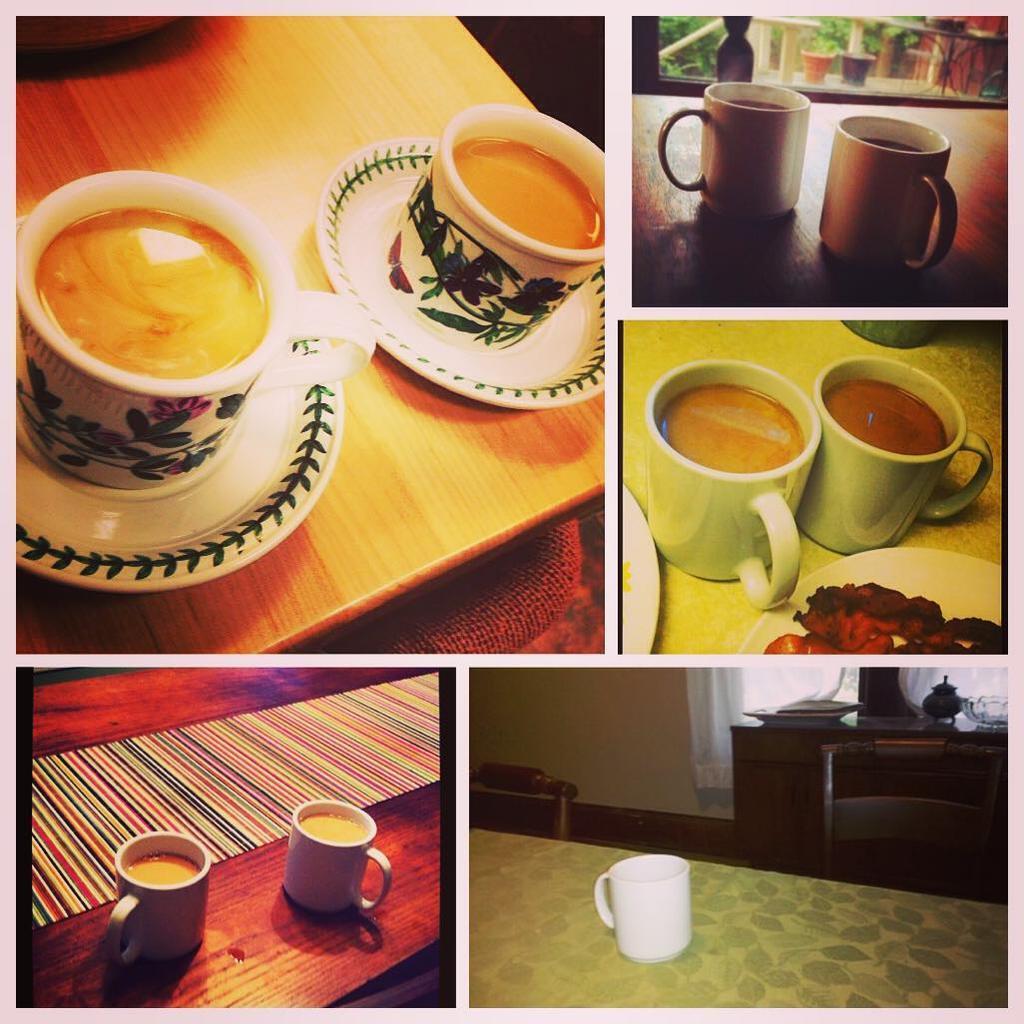How would you summarize this image in a sentence or two? In this image I can see collage photo of few cups and plates. I can also see few tables and food. 